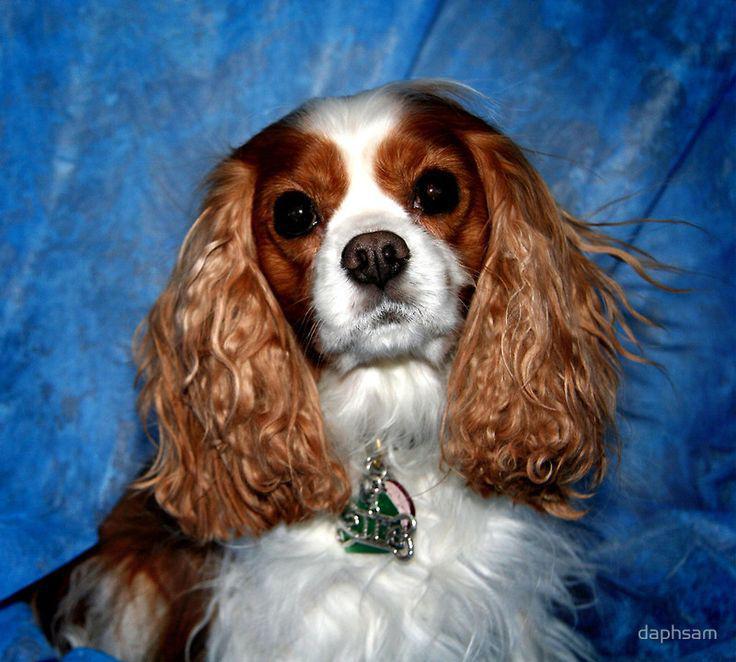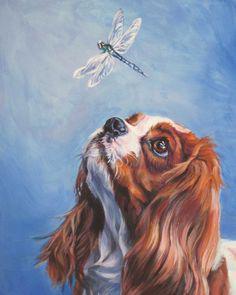The first image is the image on the left, the second image is the image on the right. Evaluate the accuracy of this statement regarding the images: "Part of a human is visible in at least one of the images.". Is it true? Answer yes or no. No. The first image is the image on the left, the second image is the image on the right. Examine the images to the left and right. Is the description "At least one image shows a spaniel on a solid blue background, and at least one image shows a spaniel gazing upward and to the left." accurate? Answer yes or no. Yes. 